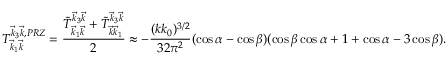<formula> <loc_0><loc_0><loc_500><loc_500>T _ { \vec { k } _ { 1 } \vec { k } } ^ { \vec { k } _ { 3 } \vec { k } , P R Z } = \frac { \tilde { T } _ { \vec { k } _ { 1 } \vec { k } } ^ { \vec { k } _ { 3 } \vec { k } } + \tilde { T } _ { \vec { k } \vec { k } _ { 1 } } ^ { \vec { k } _ { 3 } \vec { k } } } { 2 } \approx - \frac { ( k k _ { 0 } ) ^ { 3 / 2 } } { 3 2 \pi ^ { 2 } } ( \cos \alpha - \cos \beta ) ( \cos \beta \cos \alpha + 1 + \cos \alpha - 3 \cos \beta ) .</formula> 